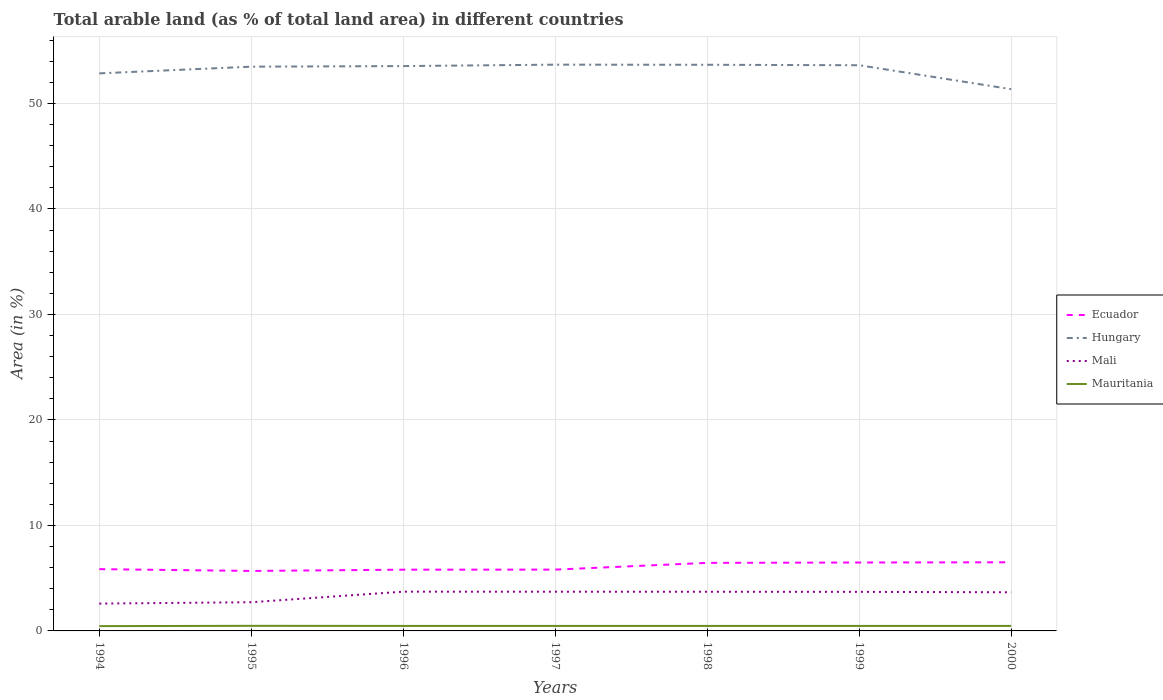Is the number of lines equal to the number of legend labels?
Offer a terse response. Yes. Across all years, what is the maximum percentage of arable land in Hungary?
Provide a short and direct response. 51.35. In which year was the percentage of arable land in Mauritania maximum?
Your response must be concise. 1994. What is the total percentage of arable land in Hungary in the graph?
Keep it short and to the point. 2.19. What is the difference between the highest and the second highest percentage of arable land in Mali?
Your answer should be very brief. 1.13. What is the difference between the highest and the lowest percentage of arable land in Ecuador?
Offer a very short reply. 3. How many lines are there?
Make the answer very short. 4. How many years are there in the graph?
Offer a very short reply. 7. What is the difference between two consecutive major ticks on the Y-axis?
Your answer should be very brief. 10. Where does the legend appear in the graph?
Keep it short and to the point. Center right. How many legend labels are there?
Give a very brief answer. 4. What is the title of the graph?
Your answer should be compact. Total arable land (as % of total land area) in different countries. Does "Fiji" appear as one of the legend labels in the graph?
Give a very brief answer. No. What is the label or title of the Y-axis?
Provide a succinct answer. Area (in %). What is the Area (in %) in Ecuador in 1994?
Your answer should be compact. 5.86. What is the Area (in %) in Hungary in 1994?
Offer a terse response. 52.85. What is the Area (in %) in Mali in 1994?
Offer a very short reply. 2.59. What is the Area (in %) in Mauritania in 1994?
Give a very brief answer. 0.46. What is the Area (in %) of Ecuador in 1995?
Give a very brief answer. 5.69. What is the Area (in %) in Hungary in 1995?
Offer a very short reply. 53.48. What is the Area (in %) in Mali in 1995?
Your answer should be compact. 2.72. What is the Area (in %) of Mauritania in 1995?
Keep it short and to the point. 0.48. What is the Area (in %) of Ecuador in 1996?
Your answer should be compact. 5.8. What is the Area (in %) of Hungary in 1996?
Offer a very short reply. 53.54. What is the Area (in %) of Mali in 1996?
Provide a succinct answer. 3.72. What is the Area (in %) of Mauritania in 1996?
Give a very brief answer. 0.47. What is the Area (in %) in Ecuador in 1997?
Ensure brevity in your answer.  5.81. What is the Area (in %) of Hungary in 1997?
Your answer should be compact. 53.67. What is the Area (in %) of Mali in 1997?
Give a very brief answer. 3.72. What is the Area (in %) in Mauritania in 1997?
Provide a short and direct response. 0.47. What is the Area (in %) in Ecuador in 1998?
Your answer should be very brief. 6.45. What is the Area (in %) of Hungary in 1998?
Make the answer very short. 53.66. What is the Area (in %) of Mali in 1998?
Make the answer very short. 3.71. What is the Area (in %) of Mauritania in 1998?
Your response must be concise. 0.47. What is the Area (in %) in Ecuador in 1999?
Your response must be concise. 6.48. What is the Area (in %) of Hungary in 1999?
Offer a very short reply. 53.62. What is the Area (in %) in Mali in 1999?
Provide a short and direct response. 3.7. What is the Area (in %) in Mauritania in 1999?
Offer a very short reply. 0.47. What is the Area (in %) in Ecuador in 2000?
Your answer should be very brief. 6.51. What is the Area (in %) in Hungary in 2000?
Offer a very short reply. 51.35. What is the Area (in %) of Mali in 2000?
Your answer should be very brief. 3.66. What is the Area (in %) in Mauritania in 2000?
Keep it short and to the point. 0.47. Across all years, what is the maximum Area (in %) in Ecuador?
Offer a terse response. 6.51. Across all years, what is the maximum Area (in %) of Hungary?
Give a very brief answer. 53.67. Across all years, what is the maximum Area (in %) in Mali?
Offer a terse response. 3.72. Across all years, what is the maximum Area (in %) of Mauritania?
Provide a succinct answer. 0.48. Across all years, what is the minimum Area (in %) of Ecuador?
Your answer should be compact. 5.69. Across all years, what is the minimum Area (in %) in Hungary?
Your answer should be very brief. 51.35. Across all years, what is the minimum Area (in %) in Mali?
Make the answer very short. 2.59. Across all years, what is the minimum Area (in %) of Mauritania?
Provide a succinct answer. 0.46. What is the total Area (in %) of Ecuador in the graph?
Your answer should be compact. 42.6. What is the total Area (in %) of Hungary in the graph?
Ensure brevity in your answer.  372.18. What is the total Area (in %) of Mali in the graph?
Your answer should be very brief. 23.83. What is the total Area (in %) of Mauritania in the graph?
Your answer should be very brief. 3.31. What is the difference between the Area (in %) in Ecuador in 1994 and that in 1995?
Give a very brief answer. 0.17. What is the difference between the Area (in %) of Hungary in 1994 and that in 1995?
Make the answer very short. -0.63. What is the difference between the Area (in %) of Mali in 1994 and that in 1995?
Provide a succinct answer. -0.13. What is the difference between the Area (in %) of Mauritania in 1994 and that in 1995?
Ensure brevity in your answer.  -0.03. What is the difference between the Area (in %) of Ecuador in 1994 and that in 1996?
Offer a very short reply. 0.05. What is the difference between the Area (in %) in Hungary in 1994 and that in 1996?
Provide a succinct answer. -0.69. What is the difference between the Area (in %) of Mali in 1994 and that in 1996?
Your answer should be compact. -1.13. What is the difference between the Area (in %) in Mauritania in 1994 and that in 1996?
Your response must be concise. -0.02. What is the difference between the Area (in %) of Ecuador in 1994 and that in 1997?
Keep it short and to the point. 0.04. What is the difference between the Area (in %) of Hungary in 1994 and that in 1997?
Make the answer very short. -0.83. What is the difference between the Area (in %) in Mali in 1994 and that in 1997?
Offer a terse response. -1.13. What is the difference between the Area (in %) in Mauritania in 1994 and that in 1997?
Provide a short and direct response. -0.02. What is the difference between the Area (in %) of Ecuador in 1994 and that in 1998?
Your answer should be compact. -0.59. What is the difference between the Area (in %) of Hungary in 1994 and that in 1998?
Make the answer very short. -0.81. What is the difference between the Area (in %) of Mali in 1994 and that in 1998?
Your answer should be very brief. -1.12. What is the difference between the Area (in %) of Mauritania in 1994 and that in 1998?
Offer a terse response. -0.02. What is the difference between the Area (in %) of Ecuador in 1994 and that in 1999?
Give a very brief answer. -0.63. What is the difference between the Area (in %) of Hungary in 1994 and that in 1999?
Provide a short and direct response. -0.77. What is the difference between the Area (in %) of Mali in 1994 and that in 1999?
Your answer should be very brief. -1.11. What is the difference between the Area (in %) of Mauritania in 1994 and that in 1999?
Make the answer very short. -0.02. What is the difference between the Area (in %) in Ecuador in 1994 and that in 2000?
Your answer should be compact. -0.65. What is the difference between the Area (in %) in Hungary in 1994 and that in 2000?
Your answer should be very brief. 1.5. What is the difference between the Area (in %) in Mali in 1994 and that in 2000?
Your response must be concise. -1.07. What is the difference between the Area (in %) in Mauritania in 1994 and that in 2000?
Your answer should be very brief. -0.02. What is the difference between the Area (in %) in Ecuador in 1995 and that in 1996?
Your answer should be compact. -0.12. What is the difference between the Area (in %) in Hungary in 1995 and that in 1996?
Offer a terse response. -0.06. What is the difference between the Area (in %) of Mali in 1995 and that in 1996?
Keep it short and to the point. -1. What is the difference between the Area (in %) in Mauritania in 1995 and that in 1996?
Your answer should be compact. 0.01. What is the difference between the Area (in %) of Ecuador in 1995 and that in 1997?
Your response must be concise. -0.13. What is the difference between the Area (in %) of Hungary in 1995 and that in 1997?
Make the answer very short. -0.19. What is the difference between the Area (in %) in Mali in 1995 and that in 1997?
Give a very brief answer. -1. What is the difference between the Area (in %) in Mauritania in 1995 and that in 1997?
Offer a very short reply. 0.01. What is the difference between the Area (in %) of Ecuador in 1995 and that in 1998?
Ensure brevity in your answer.  -0.76. What is the difference between the Area (in %) in Hungary in 1995 and that in 1998?
Keep it short and to the point. -0.18. What is the difference between the Area (in %) of Mali in 1995 and that in 1998?
Ensure brevity in your answer.  -0.99. What is the difference between the Area (in %) of Mauritania in 1995 and that in 1998?
Offer a very short reply. 0.01. What is the difference between the Area (in %) in Ecuador in 1995 and that in 1999?
Keep it short and to the point. -0.8. What is the difference between the Area (in %) in Hungary in 1995 and that in 1999?
Give a very brief answer. -0.14. What is the difference between the Area (in %) of Mali in 1995 and that in 1999?
Keep it short and to the point. -0.98. What is the difference between the Area (in %) in Mauritania in 1995 and that in 1999?
Give a very brief answer. 0.01. What is the difference between the Area (in %) in Ecuador in 1995 and that in 2000?
Provide a short and direct response. -0.82. What is the difference between the Area (in %) of Hungary in 1995 and that in 2000?
Keep it short and to the point. 2.13. What is the difference between the Area (in %) in Mali in 1995 and that in 2000?
Make the answer very short. -0.94. What is the difference between the Area (in %) of Mauritania in 1995 and that in 2000?
Provide a short and direct response. 0.01. What is the difference between the Area (in %) of Ecuador in 1996 and that in 1997?
Your response must be concise. -0.01. What is the difference between the Area (in %) of Hungary in 1996 and that in 1997?
Offer a terse response. -0.14. What is the difference between the Area (in %) of Mali in 1996 and that in 1997?
Give a very brief answer. 0. What is the difference between the Area (in %) of Ecuador in 1996 and that in 1998?
Provide a short and direct response. -0.65. What is the difference between the Area (in %) in Hungary in 1996 and that in 1998?
Ensure brevity in your answer.  -0.12. What is the difference between the Area (in %) in Mali in 1996 and that in 1998?
Provide a succinct answer. 0.01. What is the difference between the Area (in %) in Mauritania in 1996 and that in 1998?
Your answer should be very brief. 0. What is the difference between the Area (in %) in Ecuador in 1996 and that in 1999?
Offer a very short reply. -0.68. What is the difference between the Area (in %) of Hungary in 1996 and that in 1999?
Ensure brevity in your answer.  -0.08. What is the difference between the Area (in %) of Mali in 1996 and that in 1999?
Make the answer very short. 0.02. What is the difference between the Area (in %) of Mauritania in 1996 and that in 1999?
Your answer should be very brief. 0. What is the difference between the Area (in %) in Ecuador in 1996 and that in 2000?
Offer a very short reply. -0.7. What is the difference between the Area (in %) of Hungary in 1996 and that in 2000?
Provide a succinct answer. 2.19. What is the difference between the Area (in %) of Mali in 1996 and that in 2000?
Provide a short and direct response. 0.06. What is the difference between the Area (in %) in Mauritania in 1996 and that in 2000?
Offer a terse response. 0. What is the difference between the Area (in %) in Ecuador in 1997 and that in 1998?
Make the answer very short. -0.64. What is the difference between the Area (in %) in Hungary in 1997 and that in 1998?
Your response must be concise. 0.01. What is the difference between the Area (in %) of Mali in 1997 and that in 1998?
Offer a very short reply. 0. What is the difference between the Area (in %) in Mauritania in 1997 and that in 1998?
Provide a succinct answer. 0. What is the difference between the Area (in %) in Ecuador in 1997 and that in 1999?
Your response must be concise. -0.67. What is the difference between the Area (in %) in Hungary in 1997 and that in 1999?
Give a very brief answer. 0.06. What is the difference between the Area (in %) of Mali in 1997 and that in 1999?
Offer a very short reply. 0.01. What is the difference between the Area (in %) in Mauritania in 1997 and that in 1999?
Your answer should be very brief. 0. What is the difference between the Area (in %) of Ecuador in 1997 and that in 2000?
Make the answer very short. -0.69. What is the difference between the Area (in %) of Hungary in 1997 and that in 2000?
Keep it short and to the point. 2.32. What is the difference between the Area (in %) in Mali in 1997 and that in 2000?
Provide a short and direct response. 0.05. What is the difference between the Area (in %) of Mauritania in 1997 and that in 2000?
Offer a terse response. 0. What is the difference between the Area (in %) of Ecuador in 1998 and that in 1999?
Offer a very short reply. -0.03. What is the difference between the Area (in %) of Hungary in 1998 and that in 1999?
Offer a terse response. 0.04. What is the difference between the Area (in %) of Mali in 1998 and that in 1999?
Offer a very short reply. 0.01. What is the difference between the Area (in %) of Mauritania in 1998 and that in 1999?
Offer a very short reply. 0. What is the difference between the Area (in %) in Ecuador in 1998 and that in 2000?
Ensure brevity in your answer.  -0.06. What is the difference between the Area (in %) of Hungary in 1998 and that in 2000?
Ensure brevity in your answer.  2.31. What is the difference between the Area (in %) in Mali in 1998 and that in 2000?
Your answer should be very brief. 0.05. What is the difference between the Area (in %) of Ecuador in 1999 and that in 2000?
Your answer should be compact. -0.02. What is the difference between the Area (in %) in Hungary in 1999 and that in 2000?
Provide a succinct answer. 2.27. What is the difference between the Area (in %) in Mali in 1999 and that in 2000?
Offer a very short reply. 0.04. What is the difference between the Area (in %) of Ecuador in 1994 and the Area (in %) of Hungary in 1995?
Offer a very short reply. -47.63. What is the difference between the Area (in %) of Ecuador in 1994 and the Area (in %) of Mali in 1995?
Provide a short and direct response. 3.14. What is the difference between the Area (in %) of Ecuador in 1994 and the Area (in %) of Mauritania in 1995?
Provide a succinct answer. 5.37. What is the difference between the Area (in %) of Hungary in 1994 and the Area (in %) of Mali in 1995?
Provide a succinct answer. 50.13. What is the difference between the Area (in %) of Hungary in 1994 and the Area (in %) of Mauritania in 1995?
Your answer should be very brief. 52.37. What is the difference between the Area (in %) in Mali in 1994 and the Area (in %) in Mauritania in 1995?
Your answer should be compact. 2.11. What is the difference between the Area (in %) in Ecuador in 1994 and the Area (in %) in Hungary in 1996?
Offer a very short reply. -47.68. What is the difference between the Area (in %) of Ecuador in 1994 and the Area (in %) of Mali in 1996?
Your answer should be compact. 2.13. What is the difference between the Area (in %) in Ecuador in 1994 and the Area (in %) in Mauritania in 1996?
Provide a succinct answer. 5.38. What is the difference between the Area (in %) in Hungary in 1994 and the Area (in %) in Mali in 1996?
Offer a very short reply. 49.13. What is the difference between the Area (in %) of Hungary in 1994 and the Area (in %) of Mauritania in 1996?
Make the answer very short. 52.38. What is the difference between the Area (in %) in Mali in 1994 and the Area (in %) in Mauritania in 1996?
Provide a short and direct response. 2.12. What is the difference between the Area (in %) in Ecuador in 1994 and the Area (in %) in Hungary in 1997?
Ensure brevity in your answer.  -47.82. What is the difference between the Area (in %) of Ecuador in 1994 and the Area (in %) of Mali in 1997?
Give a very brief answer. 2.14. What is the difference between the Area (in %) in Ecuador in 1994 and the Area (in %) in Mauritania in 1997?
Provide a short and direct response. 5.38. What is the difference between the Area (in %) in Hungary in 1994 and the Area (in %) in Mali in 1997?
Your answer should be very brief. 49.13. What is the difference between the Area (in %) in Hungary in 1994 and the Area (in %) in Mauritania in 1997?
Your response must be concise. 52.38. What is the difference between the Area (in %) of Mali in 1994 and the Area (in %) of Mauritania in 1997?
Your answer should be very brief. 2.12. What is the difference between the Area (in %) of Ecuador in 1994 and the Area (in %) of Hungary in 1998?
Give a very brief answer. -47.81. What is the difference between the Area (in %) in Ecuador in 1994 and the Area (in %) in Mali in 1998?
Ensure brevity in your answer.  2.14. What is the difference between the Area (in %) of Ecuador in 1994 and the Area (in %) of Mauritania in 1998?
Your answer should be very brief. 5.38. What is the difference between the Area (in %) of Hungary in 1994 and the Area (in %) of Mali in 1998?
Offer a very short reply. 49.14. What is the difference between the Area (in %) in Hungary in 1994 and the Area (in %) in Mauritania in 1998?
Your response must be concise. 52.38. What is the difference between the Area (in %) of Mali in 1994 and the Area (in %) of Mauritania in 1998?
Give a very brief answer. 2.12. What is the difference between the Area (in %) in Ecuador in 1994 and the Area (in %) in Hungary in 1999?
Your answer should be compact. -47.76. What is the difference between the Area (in %) of Ecuador in 1994 and the Area (in %) of Mali in 1999?
Offer a very short reply. 2.15. What is the difference between the Area (in %) of Ecuador in 1994 and the Area (in %) of Mauritania in 1999?
Ensure brevity in your answer.  5.38. What is the difference between the Area (in %) in Hungary in 1994 and the Area (in %) in Mali in 1999?
Give a very brief answer. 49.14. What is the difference between the Area (in %) of Hungary in 1994 and the Area (in %) of Mauritania in 1999?
Keep it short and to the point. 52.38. What is the difference between the Area (in %) in Mali in 1994 and the Area (in %) in Mauritania in 1999?
Offer a terse response. 2.12. What is the difference between the Area (in %) of Ecuador in 1994 and the Area (in %) of Hungary in 2000?
Offer a very short reply. -45.49. What is the difference between the Area (in %) of Ecuador in 1994 and the Area (in %) of Mali in 2000?
Provide a succinct answer. 2.19. What is the difference between the Area (in %) in Ecuador in 1994 and the Area (in %) in Mauritania in 2000?
Your answer should be compact. 5.38. What is the difference between the Area (in %) of Hungary in 1994 and the Area (in %) of Mali in 2000?
Offer a very short reply. 49.19. What is the difference between the Area (in %) in Hungary in 1994 and the Area (in %) in Mauritania in 2000?
Give a very brief answer. 52.38. What is the difference between the Area (in %) in Mali in 1994 and the Area (in %) in Mauritania in 2000?
Offer a very short reply. 2.12. What is the difference between the Area (in %) of Ecuador in 1995 and the Area (in %) of Hungary in 1996?
Offer a terse response. -47.85. What is the difference between the Area (in %) in Ecuador in 1995 and the Area (in %) in Mali in 1996?
Your response must be concise. 1.96. What is the difference between the Area (in %) of Ecuador in 1995 and the Area (in %) of Mauritania in 1996?
Provide a succinct answer. 5.21. What is the difference between the Area (in %) in Hungary in 1995 and the Area (in %) in Mali in 1996?
Offer a terse response. 49.76. What is the difference between the Area (in %) in Hungary in 1995 and the Area (in %) in Mauritania in 1996?
Make the answer very short. 53.01. What is the difference between the Area (in %) in Mali in 1995 and the Area (in %) in Mauritania in 1996?
Make the answer very short. 2.25. What is the difference between the Area (in %) of Ecuador in 1995 and the Area (in %) of Hungary in 1997?
Provide a succinct answer. -47.99. What is the difference between the Area (in %) in Ecuador in 1995 and the Area (in %) in Mali in 1997?
Your answer should be very brief. 1.97. What is the difference between the Area (in %) in Ecuador in 1995 and the Area (in %) in Mauritania in 1997?
Make the answer very short. 5.21. What is the difference between the Area (in %) of Hungary in 1995 and the Area (in %) of Mali in 1997?
Your answer should be compact. 49.77. What is the difference between the Area (in %) in Hungary in 1995 and the Area (in %) in Mauritania in 1997?
Make the answer very short. 53.01. What is the difference between the Area (in %) in Mali in 1995 and the Area (in %) in Mauritania in 1997?
Provide a succinct answer. 2.25. What is the difference between the Area (in %) of Ecuador in 1995 and the Area (in %) of Hungary in 1998?
Offer a very short reply. -47.98. What is the difference between the Area (in %) in Ecuador in 1995 and the Area (in %) in Mali in 1998?
Your response must be concise. 1.97. What is the difference between the Area (in %) of Ecuador in 1995 and the Area (in %) of Mauritania in 1998?
Offer a very short reply. 5.21. What is the difference between the Area (in %) in Hungary in 1995 and the Area (in %) in Mali in 1998?
Offer a very short reply. 49.77. What is the difference between the Area (in %) of Hungary in 1995 and the Area (in %) of Mauritania in 1998?
Your answer should be compact. 53.01. What is the difference between the Area (in %) of Mali in 1995 and the Area (in %) of Mauritania in 1998?
Ensure brevity in your answer.  2.25. What is the difference between the Area (in %) in Ecuador in 1995 and the Area (in %) in Hungary in 1999?
Your answer should be compact. -47.93. What is the difference between the Area (in %) in Ecuador in 1995 and the Area (in %) in Mali in 1999?
Your answer should be compact. 1.98. What is the difference between the Area (in %) in Ecuador in 1995 and the Area (in %) in Mauritania in 1999?
Make the answer very short. 5.21. What is the difference between the Area (in %) of Hungary in 1995 and the Area (in %) of Mali in 1999?
Keep it short and to the point. 49.78. What is the difference between the Area (in %) of Hungary in 1995 and the Area (in %) of Mauritania in 1999?
Ensure brevity in your answer.  53.01. What is the difference between the Area (in %) of Mali in 1995 and the Area (in %) of Mauritania in 1999?
Offer a very short reply. 2.25. What is the difference between the Area (in %) in Ecuador in 1995 and the Area (in %) in Hungary in 2000?
Offer a very short reply. -45.66. What is the difference between the Area (in %) in Ecuador in 1995 and the Area (in %) in Mali in 2000?
Provide a short and direct response. 2.02. What is the difference between the Area (in %) of Ecuador in 1995 and the Area (in %) of Mauritania in 2000?
Provide a short and direct response. 5.21. What is the difference between the Area (in %) of Hungary in 1995 and the Area (in %) of Mali in 2000?
Provide a short and direct response. 49.82. What is the difference between the Area (in %) of Hungary in 1995 and the Area (in %) of Mauritania in 2000?
Your answer should be compact. 53.01. What is the difference between the Area (in %) in Mali in 1995 and the Area (in %) in Mauritania in 2000?
Provide a short and direct response. 2.25. What is the difference between the Area (in %) of Ecuador in 1996 and the Area (in %) of Hungary in 1997?
Offer a very short reply. -47.87. What is the difference between the Area (in %) in Ecuador in 1996 and the Area (in %) in Mali in 1997?
Offer a very short reply. 2.09. What is the difference between the Area (in %) of Ecuador in 1996 and the Area (in %) of Mauritania in 1997?
Ensure brevity in your answer.  5.33. What is the difference between the Area (in %) of Hungary in 1996 and the Area (in %) of Mali in 1997?
Your answer should be very brief. 49.82. What is the difference between the Area (in %) of Hungary in 1996 and the Area (in %) of Mauritania in 1997?
Ensure brevity in your answer.  53.07. What is the difference between the Area (in %) of Mali in 1996 and the Area (in %) of Mauritania in 1997?
Your answer should be compact. 3.25. What is the difference between the Area (in %) of Ecuador in 1996 and the Area (in %) of Hungary in 1998?
Offer a very short reply. -47.86. What is the difference between the Area (in %) of Ecuador in 1996 and the Area (in %) of Mali in 1998?
Your answer should be very brief. 2.09. What is the difference between the Area (in %) of Ecuador in 1996 and the Area (in %) of Mauritania in 1998?
Make the answer very short. 5.33. What is the difference between the Area (in %) in Hungary in 1996 and the Area (in %) in Mali in 1998?
Offer a terse response. 49.83. What is the difference between the Area (in %) in Hungary in 1996 and the Area (in %) in Mauritania in 1998?
Ensure brevity in your answer.  53.07. What is the difference between the Area (in %) in Mali in 1996 and the Area (in %) in Mauritania in 1998?
Offer a very short reply. 3.25. What is the difference between the Area (in %) in Ecuador in 1996 and the Area (in %) in Hungary in 1999?
Provide a succinct answer. -47.81. What is the difference between the Area (in %) in Ecuador in 1996 and the Area (in %) in Mali in 1999?
Offer a terse response. 2.1. What is the difference between the Area (in %) of Ecuador in 1996 and the Area (in %) of Mauritania in 1999?
Your answer should be compact. 5.33. What is the difference between the Area (in %) in Hungary in 1996 and the Area (in %) in Mali in 1999?
Offer a terse response. 49.83. What is the difference between the Area (in %) of Hungary in 1996 and the Area (in %) of Mauritania in 1999?
Your answer should be compact. 53.07. What is the difference between the Area (in %) of Mali in 1996 and the Area (in %) of Mauritania in 1999?
Provide a short and direct response. 3.25. What is the difference between the Area (in %) in Ecuador in 1996 and the Area (in %) in Hungary in 2000?
Give a very brief answer. -45.55. What is the difference between the Area (in %) of Ecuador in 1996 and the Area (in %) of Mali in 2000?
Ensure brevity in your answer.  2.14. What is the difference between the Area (in %) in Ecuador in 1996 and the Area (in %) in Mauritania in 2000?
Ensure brevity in your answer.  5.33. What is the difference between the Area (in %) in Hungary in 1996 and the Area (in %) in Mali in 2000?
Offer a terse response. 49.88. What is the difference between the Area (in %) of Hungary in 1996 and the Area (in %) of Mauritania in 2000?
Ensure brevity in your answer.  53.07. What is the difference between the Area (in %) of Mali in 1996 and the Area (in %) of Mauritania in 2000?
Provide a short and direct response. 3.25. What is the difference between the Area (in %) of Ecuador in 1997 and the Area (in %) of Hungary in 1998?
Give a very brief answer. -47.85. What is the difference between the Area (in %) in Ecuador in 1997 and the Area (in %) in Mali in 1998?
Your answer should be compact. 2.1. What is the difference between the Area (in %) of Ecuador in 1997 and the Area (in %) of Mauritania in 1998?
Give a very brief answer. 5.34. What is the difference between the Area (in %) of Hungary in 1997 and the Area (in %) of Mali in 1998?
Your response must be concise. 49.96. What is the difference between the Area (in %) of Hungary in 1997 and the Area (in %) of Mauritania in 1998?
Your answer should be compact. 53.2. What is the difference between the Area (in %) in Mali in 1997 and the Area (in %) in Mauritania in 1998?
Your answer should be very brief. 3.24. What is the difference between the Area (in %) of Ecuador in 1997 and the Area (in %) of Hungary in 1999?
Your answer should be very brief. -47.81. What is the difference between the Area (in %) of Ecuador in 1997 and the Area (in %) of Mali in 1999?
Offer a terse response. 2.11. What is the difference between the Area (in %) in Ecuador in 1997 and the Area (in %) in Mauritania in 1999?
Provide a short and direct response. 5.34. What is the difference between the Area (in %) of Hungary in 1997 and the Area (in %) of Mali in 1999?
Offer a very short reply. 49.97. What is the difference between the Area (in %) of Hungary in 1997 and the Area (in %) of Mauritania in 1999?
Provide a succinct answer. 53.2. What is the difference between the Area (in %) in Mali in 1997 and the Area (in %) in Mauritania in 1999?
Keep it short and to the point. 3.24. What is the difference between the Area (in %) in Ecuador in 1997 and the Area (in %) in Hungary in 2000?
Keep it short and to the point. -45.54. What is the difference between the Area (in %) of Ecuador in 1997 and the Area (in %) of Mali in 2000?
Make the answer very short. 2.15. What is the difference between the Area (in %) in Ecuador in 1997 and the Area (in %) in Mauritania in 2000?
Keep it short and to the point. 5.34. What is the difference between the Area (in %) of Hungary in 1997 and the Area (in %) of Mali in 2000?
Offer a very short reply. 50.01. What is the difference between the Area (in %) of Hungary in 1997 and the Area (in %) of Mauritania in 2000?
Offer a terse response. 53.2. What is the difference between the Area (in %) of Mali in 1997 and the Area (in %) of Mauritania in 2000?
Ensure brevity in your answer.  3.24. What is the difference between the Area (in %) of Ecuador in 1998 and the Area (in %) of Hungary in 1999?
Your answer should be very brief. -47.17. What is the difference between the Area (in %) of Ecuador in 1998 and the Area (in %) of Mali in 1999?
Your answer should be compact. 2.75. What is the difference between the Area (in %) in Ecuador in 1998 and the Area (in %) in Mauritania in 1999?
Provide a succinct answer. 5.98. What is the difference between the Area (in %) of Hungary in 1998 and the Area (in %) of Mali in 1999?
Ensure brevity in your answer.  49.96. What is the difference between the Area (in %) of Hungary in 1998 and the Area (in %) of Mauritania in 1999?
Your answer should be very brief. 53.19. What is the difference between the Area (in %) of Mali in 1998 and the Area (in %) of Mauritania in 1999?
Your answer should be compact. 3.24. What is the difference between the Area (in %) in Ecuador in 1998 and the Area (in %) in Hungary in 2000?
Provide a short and direct response. -44.9. What is the difference between the Area (in %) of Ecuador in 1998 and the Area (in %) of Mali in 2000?
Provide a succinct answer. 2.79. What is the difference between the Area (in %) of Ecuador in 1998 and the Area (in %) of Mauritania in 2000?
Your response must be concise. 5.98. What is the difference between the Area (in %) of Hungary in 1998 and the Area (in %) of Mali in 2000?
Offer a very short reply. 50. What is the difference between the Area (in %) in Hungary in 1998 and the Area (in %) in Mauritania in 2000?
Keep it short and to the point. 53.19. What is the difference between the Area (in %) in Mali in 1998 and the Area (in %) in Mauritania in 2000?
Make the answer very short. 3.24. What is the difference between the Area (in %) of Ecuador in 1999 and the Area (in %) of Hungary in 2000?
Ensure brevity in your answer.  -44.87. What is the difference between the Area (in %) of Ecuador in 1999 and the Area (in %) of Mali in 2000?
Keep it short and to the point. 2.82. What is the difference between the Area (in %) of Ecuador in 1999 and the Area (in %) of Mauritania in 2000?
Offer a terse response. 6.01. What is the difference between the Area (in %) in Hungary in 1999 and the Area (in %) in Mali in 2000?
Offer a very short reply. 49.96. What is the difference between the Area (in %) in Hungary in 1999 and the Area (in %) in Mauritania in 2000?
Provide a succinct answer. 53.15. What is the difference between the Area (in %) of Mali in 1999 and the Area (in %) of Mauritania in 2000?
Your response must be concise. 3.23. What is the average Area (in %) of Ecuador per year?
Offer a very short reply. 6.09. What is the average Area (in %) of Hungary per year?
Keep it short and to the point. 53.17. What is the average Area (in %) of Mali per year?
Offer a very short reply. 3.4. What is the average Area (in %) in Mauritania per year?
Your answer should be very brief. 0.47. In the year 1994, what is the difference between the Area (in %) of Ecuador and Area (in %) of Hungary?
Your answer should be compact. -46.99. In the year 1994, what is the difference between the Area (in %) in Ecuador and Area (in %) in Mali?
Your response must be concise. 3.27. In the year 1994, what is the difference between the Area (in %) of Ecuador and Area (in %) of Mauritania?
Your answer should be very brief. 5.4. In the year 1994, what is the difference between the Area (in %) in Hungary and Area (in %) in Mali?
Ensure brevity in your answer.  50.26. In the year 1994, what is the difference between the Area (in %) of Hungary and Area (in %) of Mauritania?
Make the answer very short. 52.39. In the year 1994, what is the difference between the Area (in %) of Mali and Area (in %) of Mauritania?
Your answer should be very brief. 2.13. In the year 1995, what is the difference between the Area (in %) in Ecuador and Area (in %) in Hungary?
Your answer should be very brief. -47.8. In the year 1995, what is the difference between the Area (in %) in Ecuador and Area (in %) in Mali?
Keep it short and to the point. 2.97. In the year 1995, what is the difference between the Area (in %) in Ecuador and Area (in %) in Mauritania?
Keep it short and to the point. 5.2. In the year 1995, what is the difference between the Area (in %) in Hungary and Area (in %) in Mali?
Give a very brief answer. 50.76. In the year 1995, what is the difference between the Area (in %) of Hungary and Area (in %) of Mauritania?
Provide a short and direct response. 53. In the year 1995, what is the difference between the Area (in %) in Mali and Area (in %) in Mauritania?
Keep it short and to the point. 2.24. In the year 1996, what is the difference between the Area (in %) of Ecuador and Area (in %) of Hungary?
Provide a succinct answer. -47.73. In the year 1996, what is the difference between the Area (in %) in Ecuador and Area (in %) in Mali?
Make the answer very short. 2.08. In the year 1996, what is the difference between the Area (in %) in Ecuador and Area (in %) in Mauritania?
Keep it short and to the point. 5.33. In the year 1996, what is the difference between the Area (in %) of Hungary and Area (in %) of Mali?
Your answer should be very brief. 49.82. In the year 1996, what is the difference between the Area (in %) in Hungary and Area (in %) in Mauritania?
Offer a terse response. 53.07. In the year 1996, what is the difference between the Area (in %) of Mali and Area (in %) of Mauritania?
Keep it short and to the point. 3.25. In the year 1997, what is the difference between the Area (in %) in Ecuador and Area (in %) in Hungary?
Your answer should be very brief. -47.86. In the year 1997, what is the difference between the Area (in %) of Ecuador and Area (in %) of Mali?
Provide a succinct answer. 2.1. In the year 1997, what is the difference between the Area (in %) of Ecuador and Area (in %) of Mauritania?
Your answer should be very brief. 5.34. In the year 1997, what is the difference between the Area (in %) in Hungary and Area (in %) in Mali?
Provide a succinct answer. 49.96. In the year 1997, what is the difference between the Area (in %) in Hungary and Area (in %) in Mauritania?
Offer a terse response. 53.2. In the year 1997, what is the difference between the Area (in %) of Mali and Area (in %) of Mauritania?
Make the answer very short. 3.24. In the year 1998, what is the difference between the Area (in %) of Ecuador and Area (in %) of Hungary?
Your answer should be very brief. -47.21. In the year 1998, what is the difference between the Area (in %) of Ecuador and Area (in %) of Mali?
Provide a succinct answer. 2.74. In the year 1998, what is the difference between the Area (in %) in Ecuador and Area (in %) in Mauritania?
Offer a terse response. 5.98. In the year 1998, what is the difference between the Area (in %) in Hungary and Area (in %) in Mali?
Your answer should be very brief. 49.95. In the year 1998, what is the difference between the Area (in %) of Hungary and Area (in %) of Mauritania?
Ensure brevity in your answer.  53.19. In the year 1998, what is the difference between the Area (in %) in Mali and Area (in %) in Mauritania?
Your answer should be very brief. 3.24. In the year 1999, what is the difference between the Area (in %) in Ecuador and Area (in %) in Hungary?
Ensure brevity in your answer.  -47.14. In the year 1999, what is the difference between the Area (in %) in Ecuador and Area (in %) in Mali?
Give a very brief answer. 2.78. In the year 1999, what is the difference between the Area (in %) in Ecuador and Area (in %) in Mauritania?
Your response must be concise. 6.01. In the year 1999, what is the difference between the Area (in %) of Hungary and Area (in %) of Mali?
Offer a very short reply. 49.91. In the year 1999, what is the difference between the Area (in %) of Hungary and Area (in %) of Mauritania?
Ensure brevity in your answer.  53.15. In the year 1999, what is the difference between the Area (in %) in Mali and Area (in %) in Mauritania?
Your answer should be compact. 3.23. In the year 2000, what is the difference between the Area (in %) in Ecuador and Area (in %) in Hungary?
Ensure brevity in your answer.  -44.84. In the year 2000, what is the difference between the Area (in %) in Ecuador and Area (in %) in Mali?
Offer a very short reply. 2.85. In the year 2000, what is the difference between the Area (in %) of Ecuador and Area (in %) of Mauritania?
Provide a succinct answer. 6.03. In the year 2000, what is the difference between the Area (in %) in Hungary and Area (in %) in Mali?
Your response must be concise. 47.69. In the year 2000, what is the difference between the Area (in %) in Hungary and Area (in %) in Mauritania?
Keep it short and to the point. 50.88. In the year 2000, what is the difference between the Area (in %) in Mali and Area (in %) in Mauritania?
Make the answer very short. 3.19. What is the ratio of the Area (in %) of Ecuador in 1994 to that in 1995?
Your answer should be very brief. 1.03. What is the ratio of the Area (in %) in Hungary in 1994 to that in 1995?
Make the answer very short. 0.99. What is the ratio of the Area (in %) in Mali in 1994 to that in 1995?
Provide a short and direct response. 0.95. What is the ratio of the Area (in %) in Mauritania in 1994 to that in 1995?
Your response must be concise. 0.94. What is the ratio of the Area (in %) in Ecuador in 1994 to that in 1996?
Make the answer very short. 1.01. What is the ratio of the Area (in %) in Hungary in 1994 to that in 1996?
Keep it short and to the point. 0.99. What is the ratio of the Area (in %) in Mali in 1994 to that in 1996?
Your answer should be very brief. 0.7. What is the ratio of the Area (in %) of Mauritania in 1994 to that in 1996?
Your answer should be very brief. 0.96. What is the ratio of the Area (in %) of Ecuador in 1994 to that in 1997?
Offer a very short reply. 1.01. What is the ratio of the Area (in %) in Hungary in 1994 to that in 1997?
Ensure brevity in your answer.  0.98. What is the ratio of the Area (in %) in Mali in 1994 to that in 1997?
Offer a terse response. 0.7. What is the ratio of the Area (in %) of Mauritania in 1994 to that in 1997?
Offer a very short reply. 0.96. What is the ratio of the Area (in %) of Ecuador in 1994 to that in 1998?
Provide a short and direct response. 0.91. What is the ratio of the Area (in %) in Hungary in 1994 to that in 1998?
Your response must be concise. 0.98. What is the ratio of the Area (in %) of Mali in 1994 to that in 1998?
Offer a terse response. 0.7. What is the ratio of the Area (in %) of Mauritania in 1994 to that in 1998?
Your response must be concise. 0.96. What is the ratio of the Area (in %) of Ecuador in 1994 to that in 1999?
Offer a very short reply. 0.9. What is the ratio of the Area (in %) in Hungary in 1994 to that in 1999?
Provide a short and direct response. 0.99. What is the ratio of the Area (in %) of Mali in 1994 to that in 1999?
Offer a terse response. 0.7. What is the ratio of the Area (in %) of Mauritania in 1994 to that in 1999?
Provide a short and direct response. 0.96. What is the ratio of the Area (in %) of Ecuador in 1994 to that in 2000?
Your answer should be very brief. 0.9. What is the ratio of the Area (in %) in Hungary in 1994 to that in 2000?
Your response must be concise. 1.03. What is the ratio of the Area (in %) in Mali in 1994 to that in 2000?
Provide a succinct answer. 0.71. What is the ratio of the Area (in %) in Mauritania in 1994 to that in 2000?
Your answer should be compact. 0.96. What is the ratio of the Area (in %) in Ecuador in 1995 to that in 1996?
Provide a succinct answer. 0.98. What is the ratio of the Area (in %) in Mali in 1995 to that in 1996?
Offer a very short reply. 0.73. What is the ratio of the Area (in %) in Mauritania in 1995 to that in 1996?
Ensure brevity in your answer.  1.02. What is the ratio of the Area (in %) in Ecuador in 1995 to that in 1997?
Give a very brief answer. 0.98. What is the ratio of the Area (in %) of Mali in 1995 to that in 1997?
Give a very brief answer. 0.73. What is the ratio of the Area (in %) of Mauritania in 1995 to that in 1997?
Provide a succinct answer. 1.02. What is the ratio of the Area (in %) of Ecuador in 1995 to that in 1998?
Keep it short and to the point. 0.88. What is the ratio of the Area (in %) of Hungary in 1995 to that in 1998?
Offer a terse response. 1. What is the ratio of the Area (in %) of Mali in 1995 to that in 1998?
Your response must be concise. 0.73. What is the ratio of the Area (in %) in Mauritania in 1995 to that in 1998?
Give a very brief answer. 1.02. What is the ratio of the Area (in %) of Ecuador in 1995 to that in 1999?
Make the answer very short. 0.88. What is the ratio of the Area (in %) in Mali in 1995 to that in 1999?
Ensure brevity in your answer.  0.73. What is the ratio of the Area (in %) of Mauritania in 1995 to that in 1999?
Keep it short and to the point. 1.02. What is the ratio of the Area (in %) of Ecuador in 1995 to that in 2000?
Provide a succinct answer. 0.87. What is the ratio of the Area (in %) of Hungary in 1995 to that in 2000?
Provide a short and direct response. 1.04. What is the ratio of the Area (in %) of Mali in 1995 to that in 2000?
Ensure brevity in your answer.  0.74. What is the ratio of the Area (in %) in Mauritania in 1995 to that in 2000?
Provide a succinct answer. 1.02. What is the ratio of the Area (in %) of Mauritania in 1996 to that in 1997?
Offer a terse response. 1. What is the ratio of the Area (in %) in Ecuador in 1996 to that in 1998?
Ensure brevity in your answer.  0.9. What is the ratio of the Area (in %) in Mali in 1996 to that in 1998?
Your answer should be very brief. 1. What is the ratio of the Area (in %) of Mauritania in 1996 to that in 1998?
Give a very brief answer. 1. What is the ratio of the Area (in %) of Ecuador in 1996 to that in 1999?
Your answer should be compact. 0.9. What is the ratio of the Area (in %) of Hungary in 1996 to that in 1999?
Your answer should be very brief. 1. What is the ratio of the Area (in %) in Mali in 1996 to that in 1999?
Offer a very short reply. 1. What is the ratio of the Area (in %) of Ecuador in 1996 to that in 2000?
Provide a succinct answer. 0.89. What is the ratio of the Area (in %) of Hungary in 1996 to that in 2000?
Your answer should be very brief. 1.04. What is the ratio of the Area (in %) of Mali in 1996 to that in 2000?
Give a very brief answer. 1.02. What is the ratio of the Area (in %) of Mauritania in 1996 to that in 2000?
Your response must be concise. 1. What is the ratio of the Area (in %) of Ecuador in 1997 to that in 1998?
Give a very brief answer. 0.9. What is the ratio of the Area (in %) in Mali in 1997 to that in 1998?
Provide a short and direct response. 1. What is the ratio of the Area (in %) of Mauritania in 1997 to that in 1998?
Your response must be concise. 1. What is the ratio of the Area (in %) of Ecuador in 1997 to that in 1999?
Provide a short and direct response. 0.9. What is the ratio of the Area (in %) in Mali in 1997 to that in 1999?
Your answer should be very brief. 1. What is the ratio of the Area (in %) of Ecuador in 1997 to that in 2000?
Make the answer very short. 0.89. What is the ratio of the Area (in %) in Hungary in 1997 to that in 2000?
Offer a very short reply. 1.05. What is the ratio of the Area (in %) in Mali in 1997 to that in 2000?
Provide a short and direct response. 1.01. What is the ratio of the Area (in %) in Hungary in 1998 to that in 1999?
Your response must be concise. 1. What is the ratio of the Area (in %) in Mali in 1998 to that in 1999?
Provide a succinct answer. 1. What is the ratio of the Area (in %) in Mauritania in 1998 to that in 1999?
Your answer should be compact. 1. What is the ratio of the Area (in %) of Ecuador in 1998 to that in 2000?
Give a very brief answer. 0.99. What is the ratio of the Area (in %) of Hungary in 1998 to that in 2000?
Give a very brief answer. 1.05. What is the ratio of the Area (in %) in Mali in 1998 to that in 2000?
Your answer should be compact. 1.01. What is the ratio of the Area (in %) in Hungary in 1999 to that in 2000?
Your response must be concise. 1.04. What is the ratio of the Area (in %) in Mali in 1999 to that in 2000?
Provide a short and direct response. 1.01. What is the ratio of the Area (in %) in Mauritania in 1999 to that in 2000?
Keep it short and to the point. 1. What is the difference between the highest and the second highest Area (in %) of Ecuador?
Provide a succinct answer. 0.02. What is the difference between the highest and the second highest Area (in %) in Hungary?
Offer a terse response. 0.01. What is the difference between the highest and the second highest Area (in %) in Mali?
Give a very brief answer. 0. What is the difference between the highest and the second highest Area (in %) in Mauritania?
Provide a short and direct response. 0.01. What is the difference between the highest and the lowest Area (in %) in Ecuador?
Make the answer very short. 0.82. What is the difference between the highest and the lowest Area (in %) of Hungary?
Your response must be concise. 2.32. What is the difference between the highest and the lowest Area (in %) of Mali?
Provide a succinct answer. 1.13. What is the difference between the highest and the lowest Area (in %) of Mauritania?
Provide a short and direct response. 0.03. 